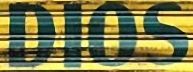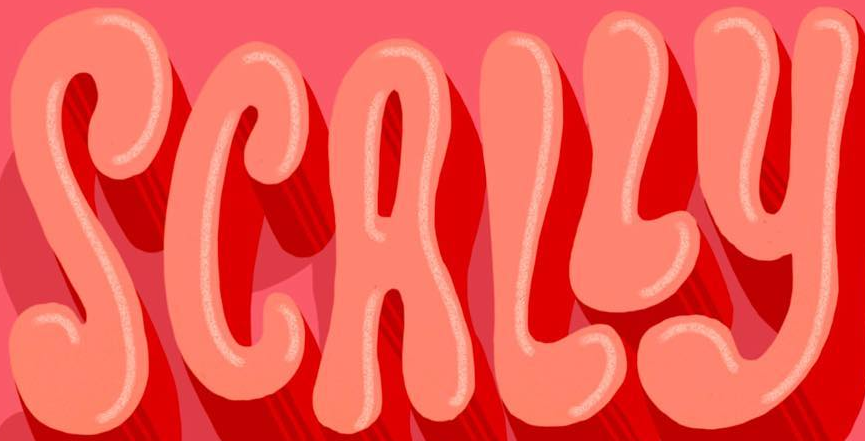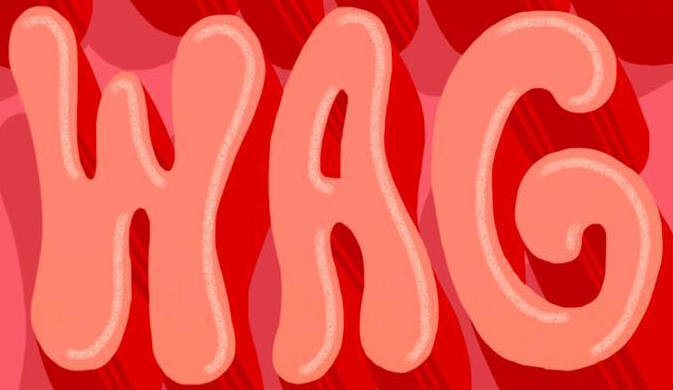What words are shown in these images in order, separated by a semicolon? DIOS; SCALLY; WAG 